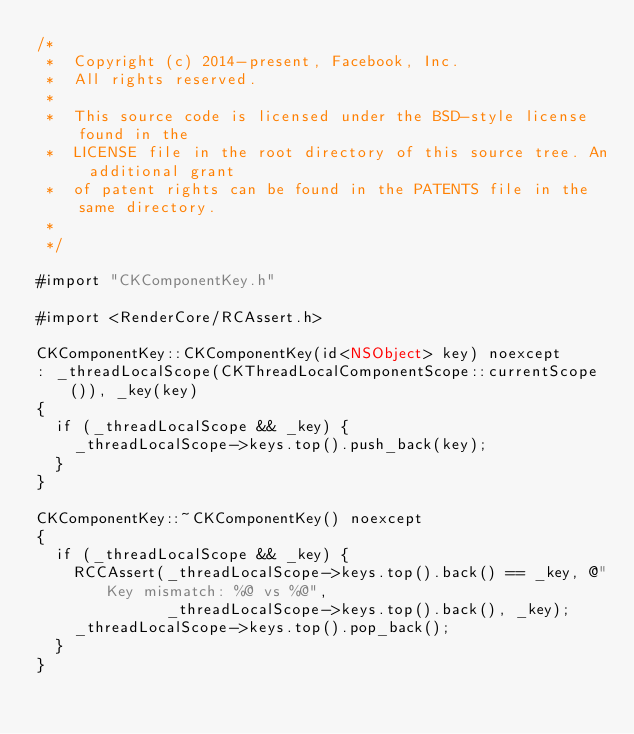Convert code to text. <code><loc_0><loc_0><loc_500><loc_500><_ObjectiveC_>/*
 *  Copyright (c) 2014-present, Facebook, Inc.
 *  All rights reserved.
 *
 *  This source code is licensed under the BSD-style license found in the
 *  LICENSE file in the root directory of this source tree. An additional grant
 *  of patent rights can be found in the PATENTS file in the same directory.
 *
 */

#import "CKComponentKey.h"

#import <RenderCore/RCAssert.h>

CKComponentKey::CKComponentKey(id<NSObject> key) noexcept
: _threadLocalScope(CKThreadLocalComponentScope::currentScope()), _key(key)
{
  if (_threadLocalScope && _key) {
    _threadLocalScope->keys.top().push_back(key);
  }
}

CKComponentKey::~CKComponentKey() noexcept
{
  if (_threadLocalScope && _key) {
    RCCAssert(_threadLocalScope->keys.top().back() == _key, @"Key mismatch: %@ vs %@",
              _threadLocalScope->keys.top().back(), _key);
    _threadLocalScope->keys.top().pop_back();
  }
}
</code> 